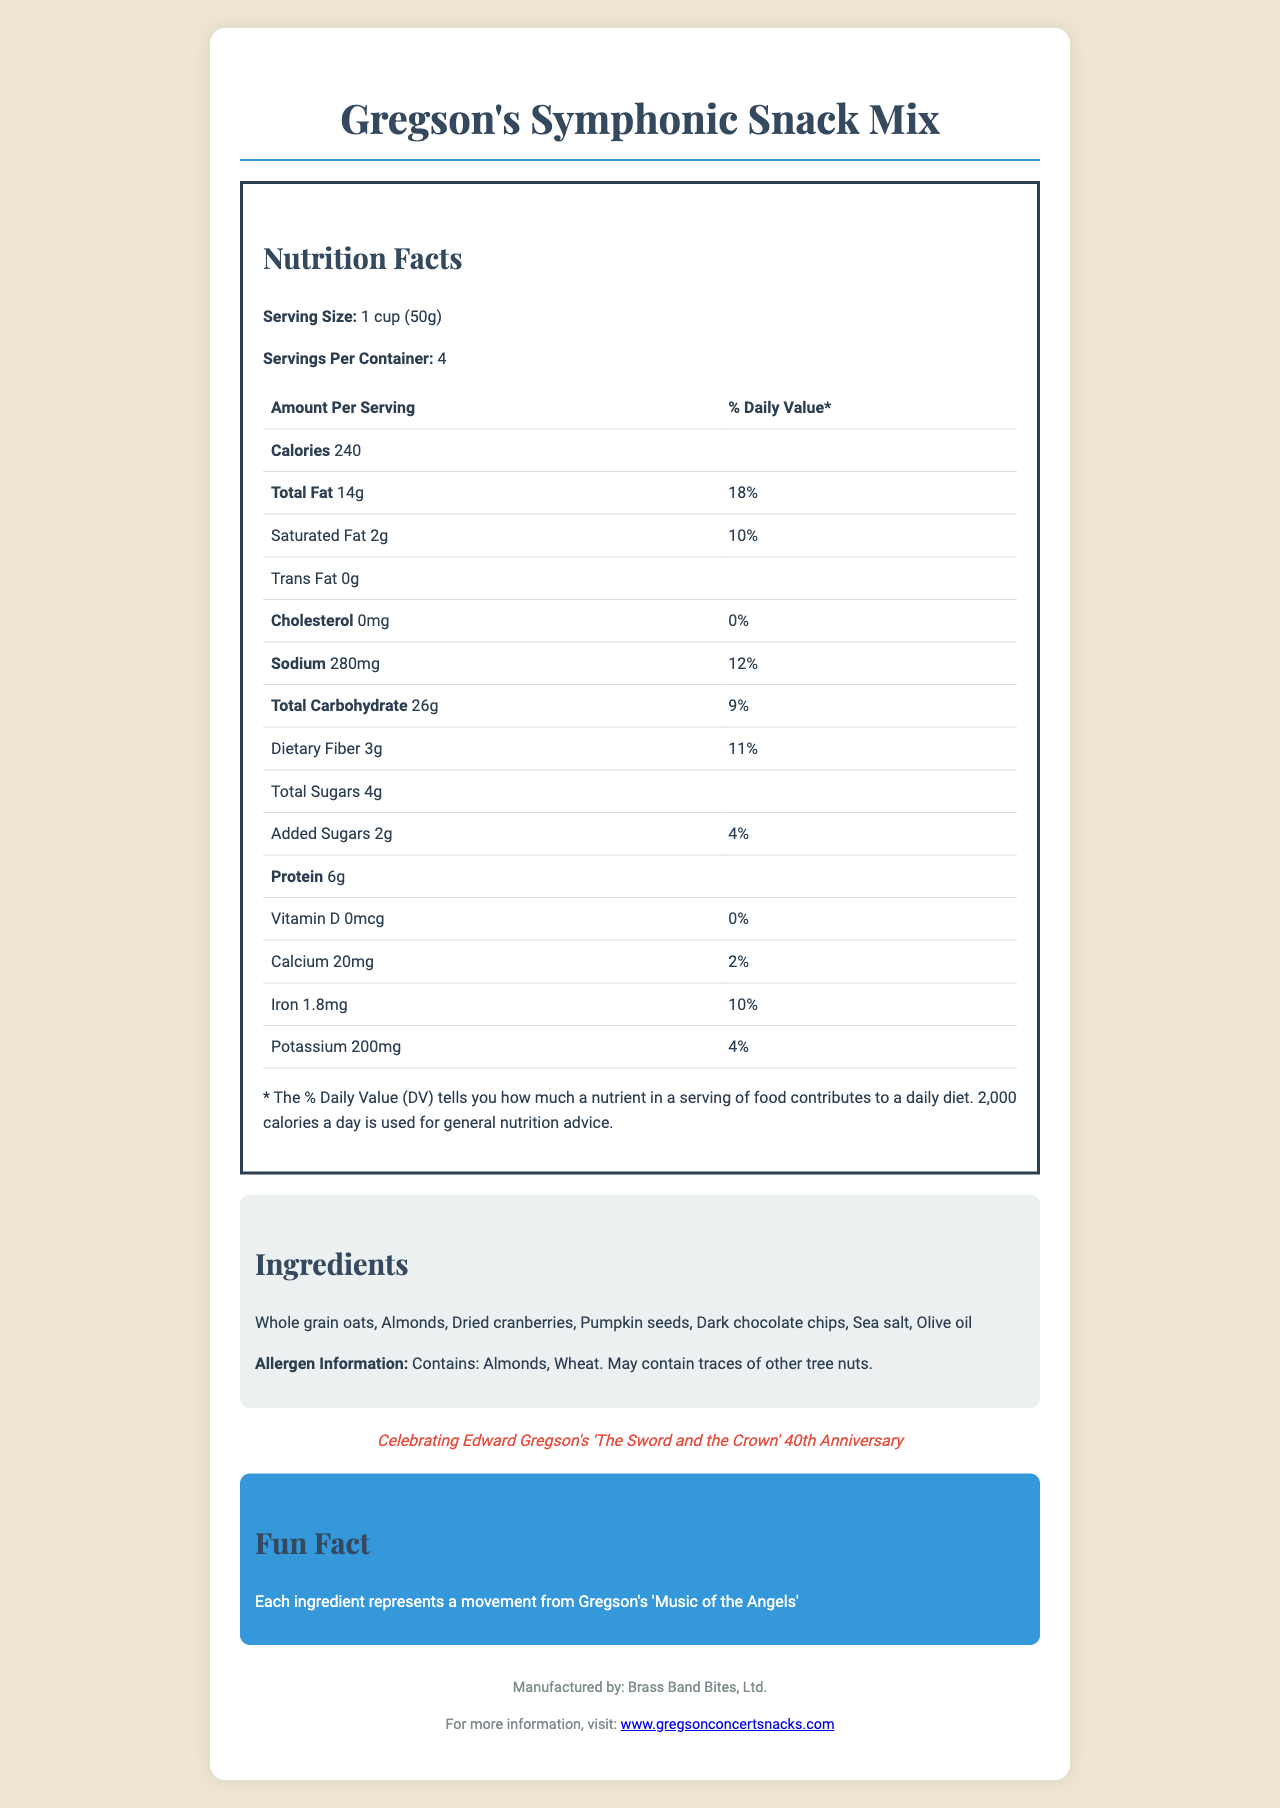what is the serving size? The serving size is mentioned directly in the document under the "Nutrition Facts" section.
Answer: 1 cup (50g) how many calories are in one serving? The document states in the "Nutrition Facts" section that there are 240 calories per serving.
Answer: 240 calories what ingredients are in Gregson's Symphonic Snack Mix? The ingredients are listed in the "Ingredients" section of the document.
Answer: Whole grain oats, Almonds, Dried cranberries, Pumpkin seeds, Dark chocolate chips, Sea salt, Olive oil how much sodium is there per serving? Under the "Nutrition Facts" section, it is mentioned that there is 280mg of sodium per serving.
Answer: 280mg what is the allergy information provided for the snack mix? The allergen information is listed under the "Ingredients" section of the document.
Answer: Contains: Almonds, Wheat. May contain traces of other tree nuts. what is the total fat content in one serving of the snack mix? A. 10g B. 14g C. 18g According to the "Nutrition Facts" section, the total fat content per serving is 14g.
Answer: B what percentage of the daily value for dietary fiber does one serving provide? A. 9% B. 10% C. 11% D. 12% The "Nutrition Facts" section states that the daily value percentage for dietary fiber is 11%.
Answer: C is this snack mix high in cholesterol? The "Nutrition Facts" section lists the cholesterol content as 0mg, which is 0% of the daily value, indicating it is not high in cholesterol.
Answer: No how many grams of protein are in one serving? The "Nutrition Facts" section specifies that there are 6g of protein per serving.
Answer: 6g what unique information is given about the ingredients related to Edward Gregson? This fun fact is stated in the "Fun Fact" section of the document.
Answer: Each ingredient represents a movement from Gregson's 'Music of the Angels' describe the purpose and main features of this document. The document provides nutritional information per serving, including calories, fat, sodium, and other dietary components. It lists the ingredients used in the snack and states the allergens. It also includes a commemorative message and a fun fact related to Edward Gregson's musical works. The manufacturer and website for further information are also provided.
Answer: The document is a Nutrition Facts Label for "Gregson's Symphonic Snack Mix," a commemorative snack pack celebrating Edward Gregson's 'The Sword and the Crown' 40th Anniversary. It includes comprehensive nutritional information, ingredient details, allergen warnings, a fun fact about the ingredients, and manufacturer information. what is Edward Gregson’s relationship to the snack mix as mentioned in the document? The commemorative text in the document highlights the celebration of Edward Gregson’s 'The Sword and the Crown' 40th Anniversary.
Answer: Celebrating Edward Gregson's 'The Sword and the Crown' 40th Anniversary how much Vitamin D is in one serving of the snack mix? The "Nutrition Facts" section indicates that the Vitamin D content per serving is 0mcg.
Answer: 0mcg what company manufactures Gregson's Symphonic Snack Mix? The manufacturer is mentioned at the bottom of the document.
Answer: Brass Band Bites, Ltd. where can more information about Gregson's Symphonic Snack Mix be found? The website for more information is provided at the bottom of the document in the manufacturer section.
Answer: www.gregsonconcertsnacks.com what is the total carbohydrate content in one serving? The "Nutrition Facts" section states that the total carbohydrate content per serving is 26g.
Answer: 26g does the document specify the number of grams of trans fat? In the "Nutrition Facts" section, the document clearly states that there are 0g of trans fat per serving.
Answer: Yes, it specifies 0g why is this snack mix commemorative? The commemorative text explains that the snack pack celebrates the 40th anniversary of Edward Gregson's 'The Sword and the Crown.'
Answer: Celebrating Edward Gregson's 'The Sword and the Crown' 40th Anniversary what is the daily value percentage for calcium in one serving? According to the "Nutrition Facts" section, the daily value percentage for calcium in one serving is 2%.
Answer: 2% what fun fact is shared about the ingredients? The fun fact about the ingredients is mentioned in the "Fun Fact" section.
Answer: Each ingredient represents a movement from Gregson's 'Music of the Angels' how many servings are in each container of Gregson's Symphonic Snack Mix? The document specifies in the "Nutrition Facts" section that there are 4 servings per container.
Answer: 4 what is the design of the document like, and how does it present information? The document uses a serif-font for headings and a sans-serif font for the body text. The layout is visually appealing with sections separated by borders and differing background colors. The text is clear, and nutritional values are easily readable from the table. The commemorative message and fun fact add a personalized touch suitable for the theme.
Answer: The document has a clean and elegant design with a cream background and dark text. Important sections like "Nutrition Facts," "Ingredients," and "Fun Fact" are clearly labeled and structured. Nutritional information is presented in a table format. The document ends with manufacturer details and a commemorative message related to Edward Gregson. 